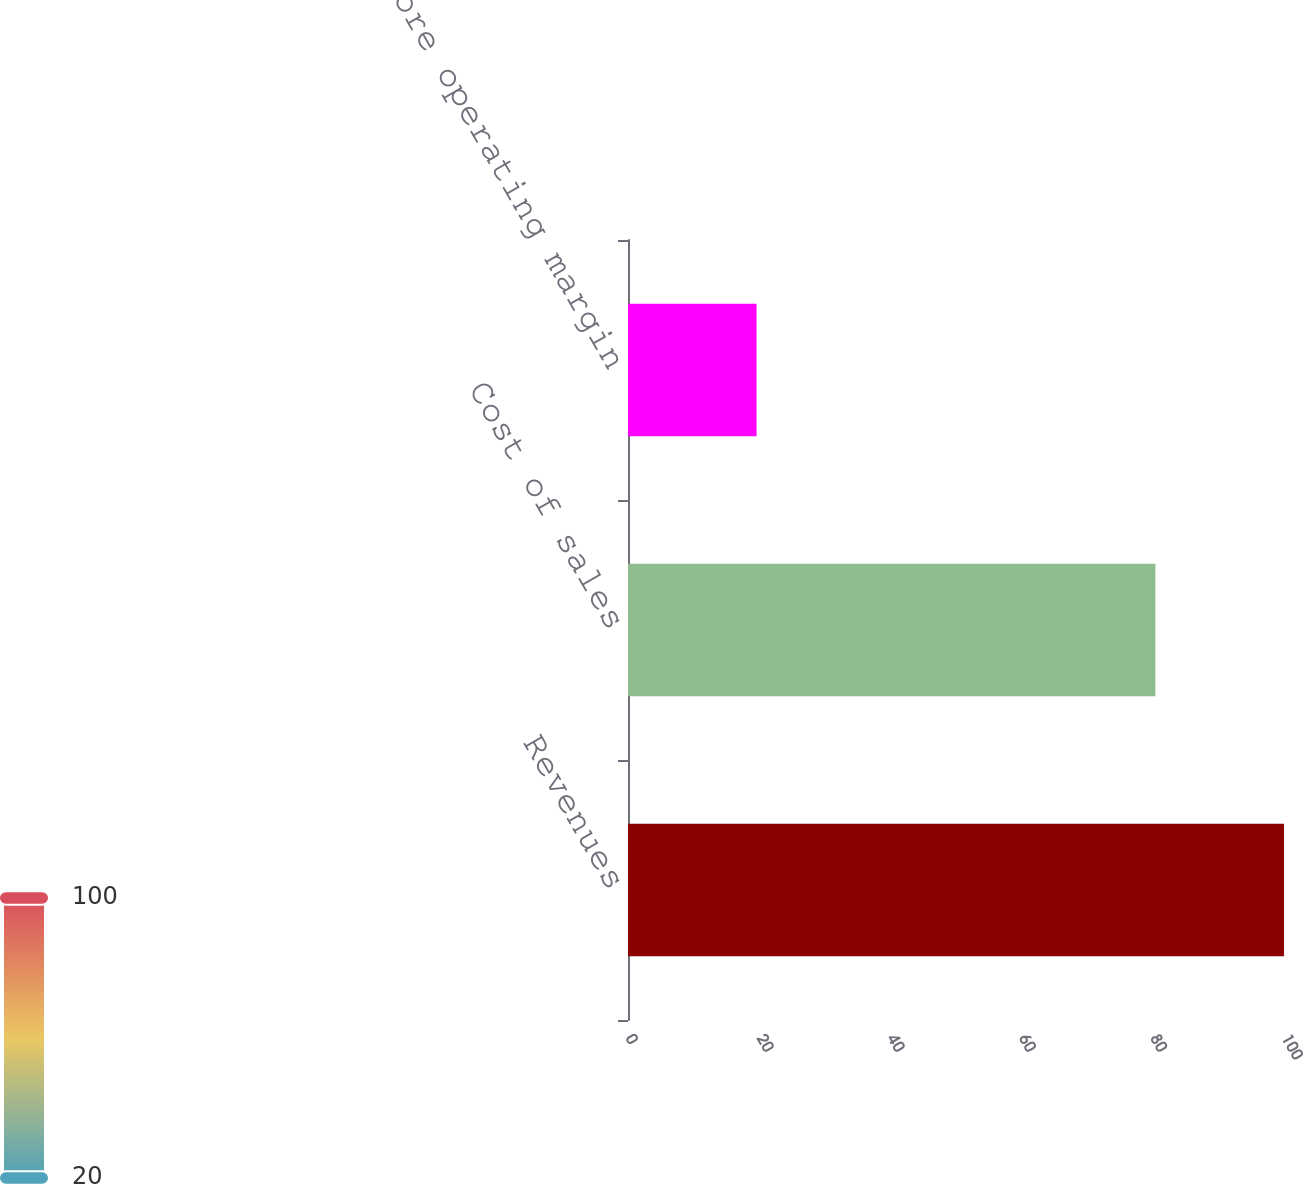Convert chart to OTSL. <chart><loc_0><loc_0><loc_500><loc_500><bar_chart><fcel>Revenues<fcel>Cost of sales<fcel>Store operating margin<nl><fcel>100<fcel>80.4<fcel>19.6<nl></chart> 